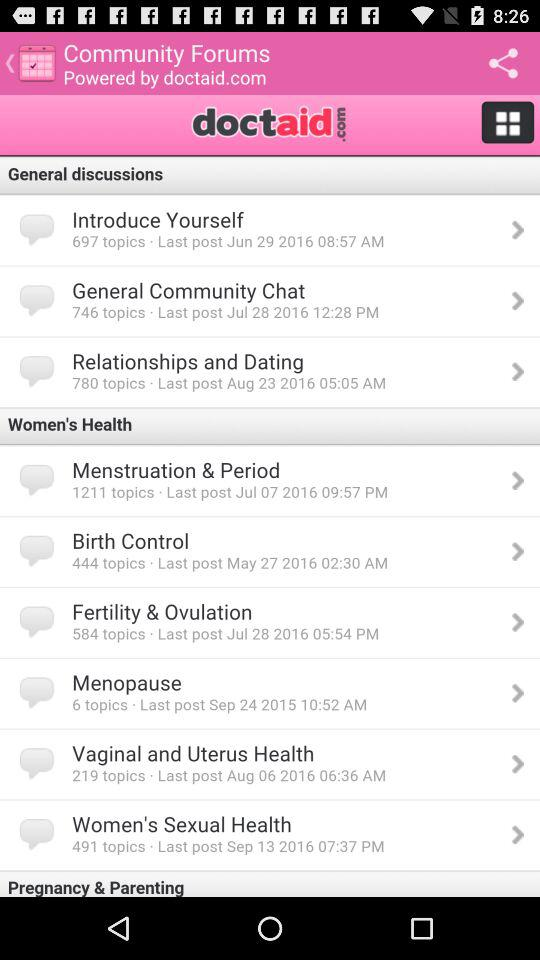By whom is "Community Forums" powered? "Community Forums" is powered by doctaid.com. 